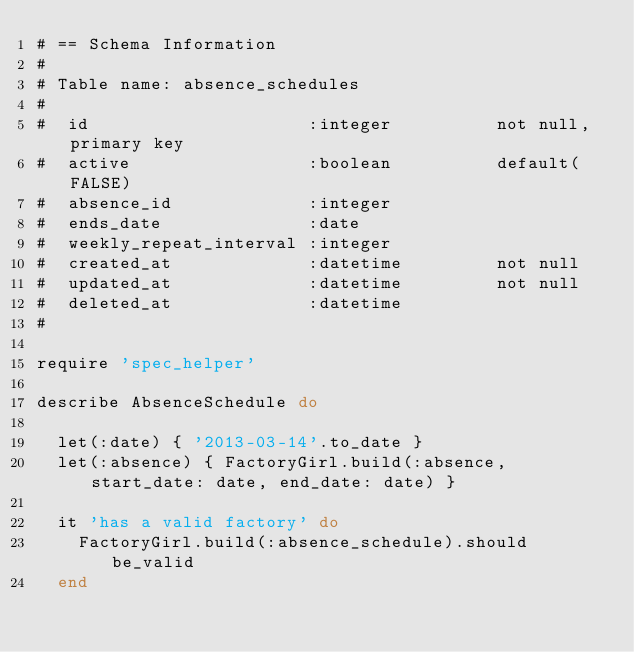<code> <loc_0><loc_0><loc_500><loc_500><_Ruby_># == Schema Information
#
# Table name: absence_schedules
#
#  id                     :integer          not null, primary key
#  active                 :boolean          default(FALSE)
#  absence_id             :integer
#  ends_date              :date
#  weekly_repeat_interval :integer
#  created_at             :datetime         not null
#  updated_at             :datetime         not null
#  deleted_at             :datetime
#

require 'spec_helper'

describe AbsenceSchedule do

  let(:date) { '2013-03-14'.to_date }
  let(:absence) { FactoryGirl.build(:absence, start_date: date, end_date: date) }

  it 'has a valid factory' do
    FactoryGirl.build(:absence_schedule).should be_valid
  end
</code> 